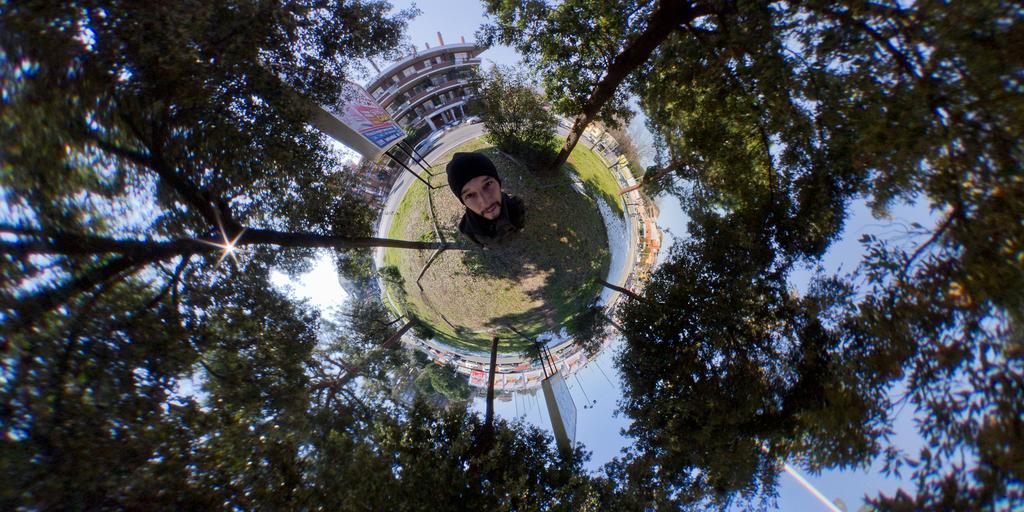Describe this image in one or two sentences. In this image there is a person standing on a land, around him there are plants, in the background there is a building and a board, on that board there is some text. 